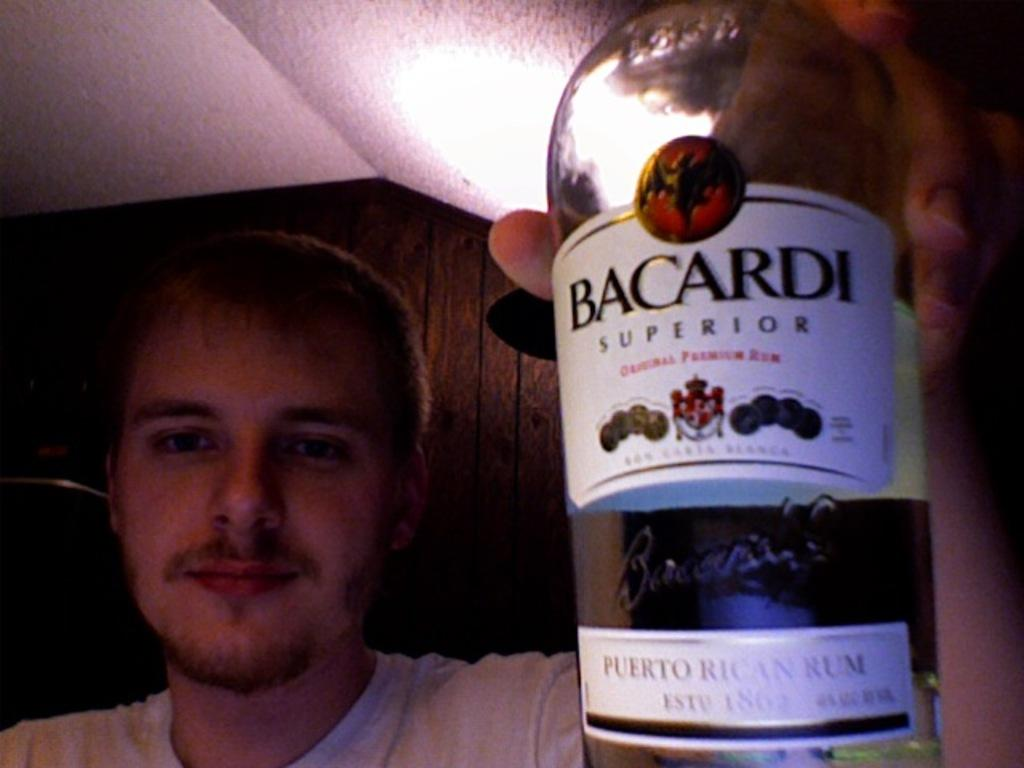<image>
Give a short and clear explanation of the subsequent image. A man holds up a bottle of Bacardi superior rum. 